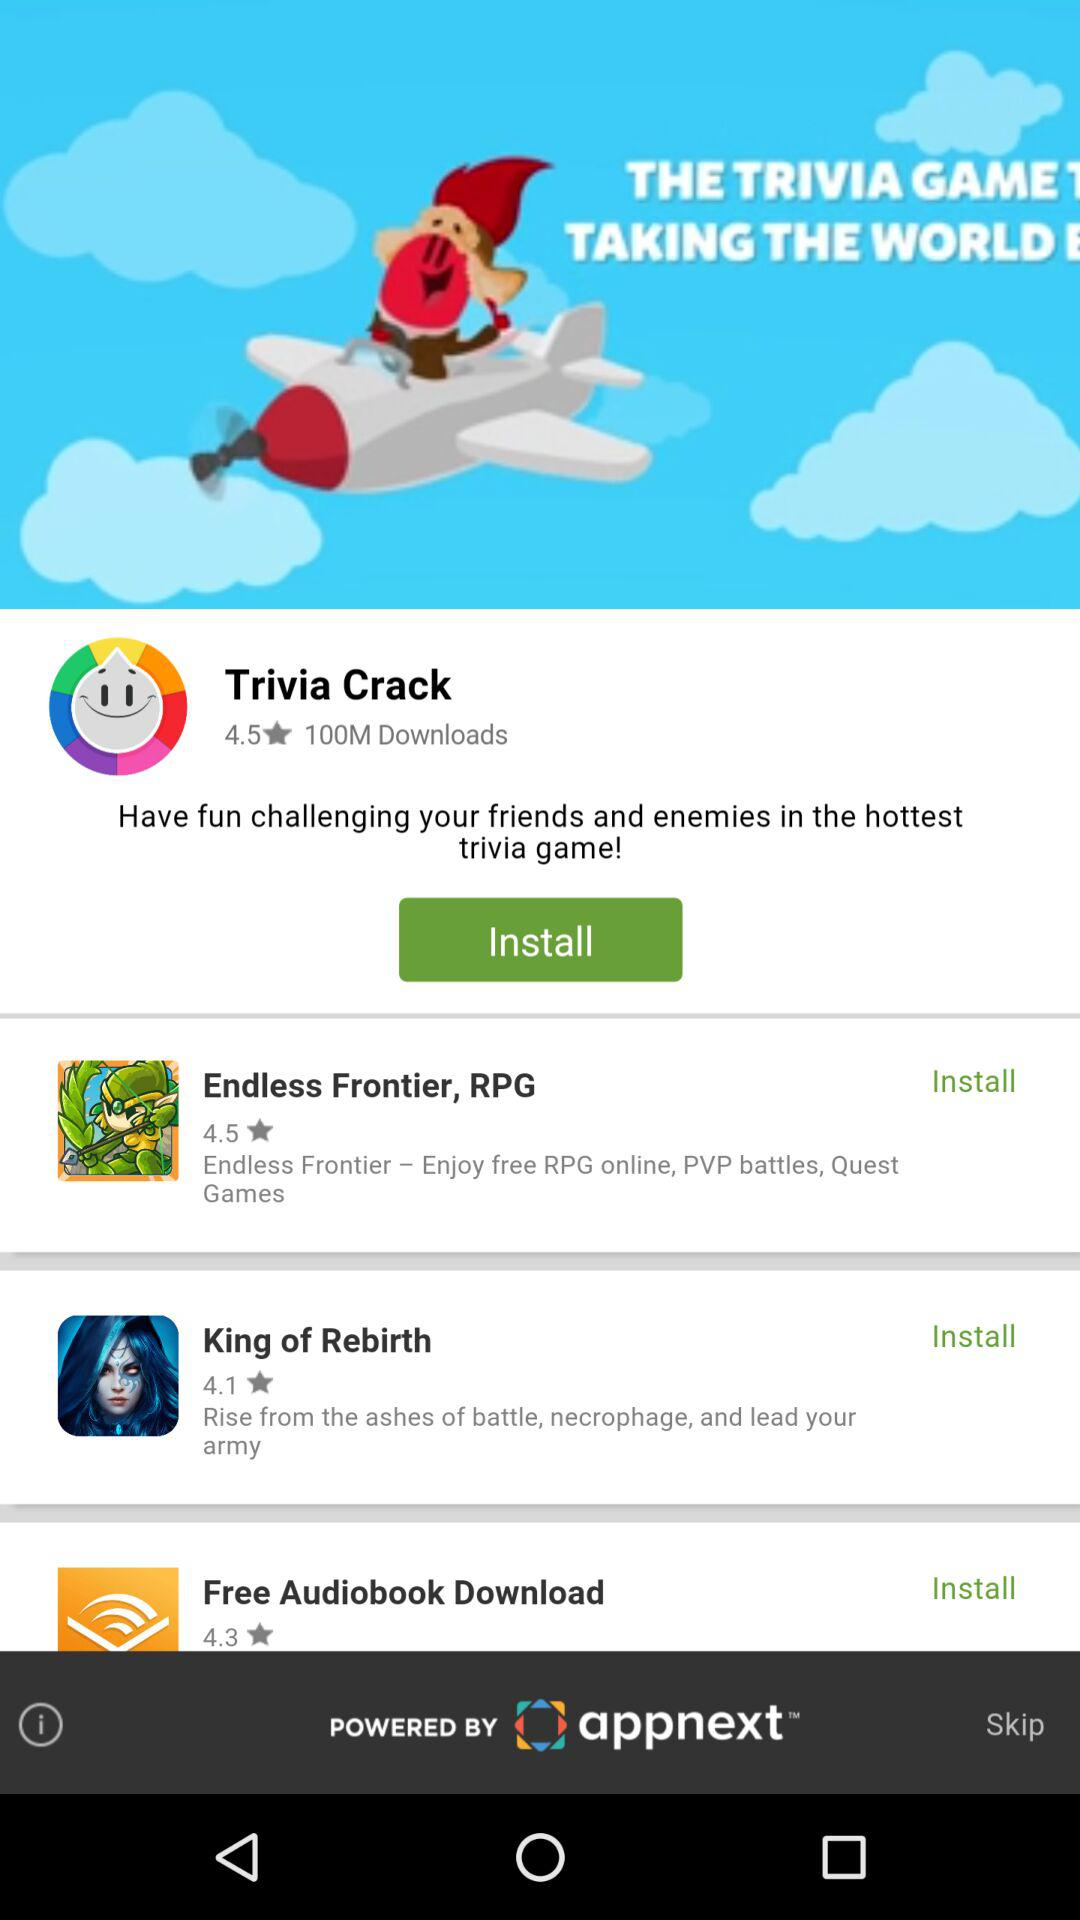Which game has 100 million downloads? The game "Trivia Crack" has 100 million downloads. 